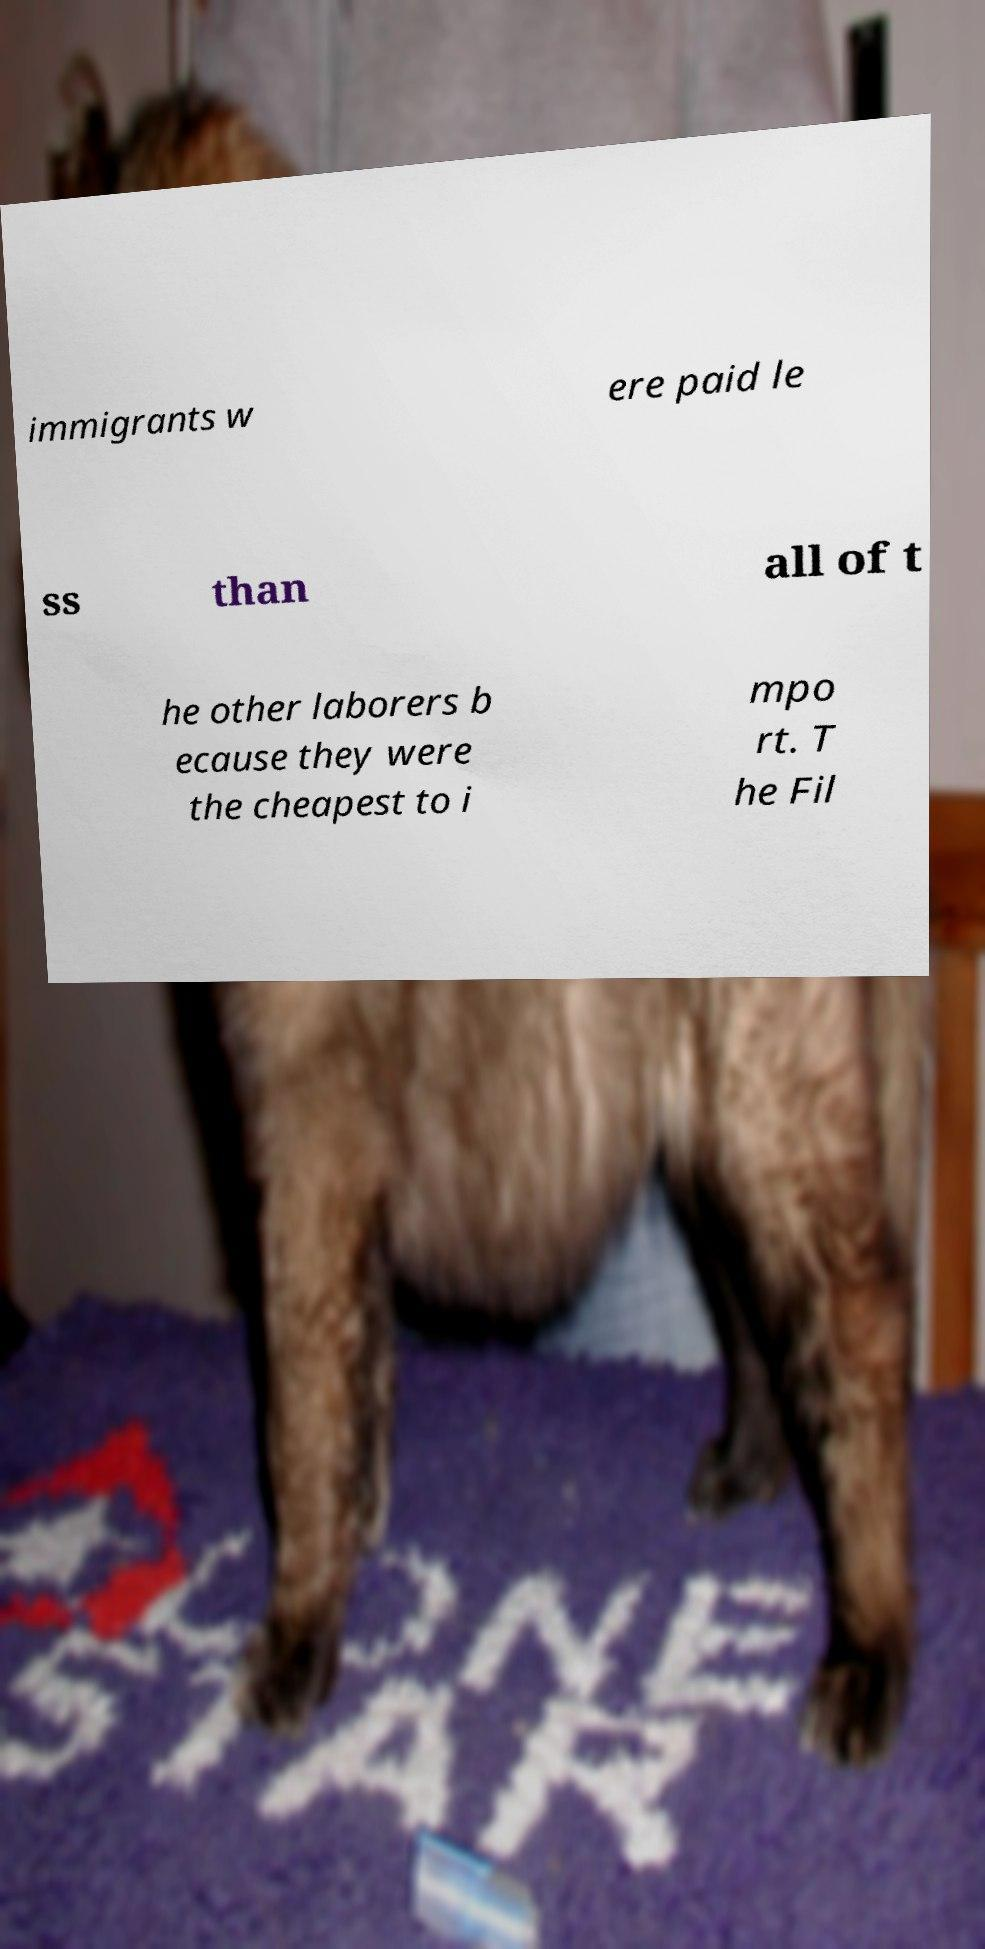Can you accurately transcribe the text from the provided image for me? immigrants w ere paid le ss than all of t he other laborers b ecause they were the cheapest to i mpo rt. T he Fil 